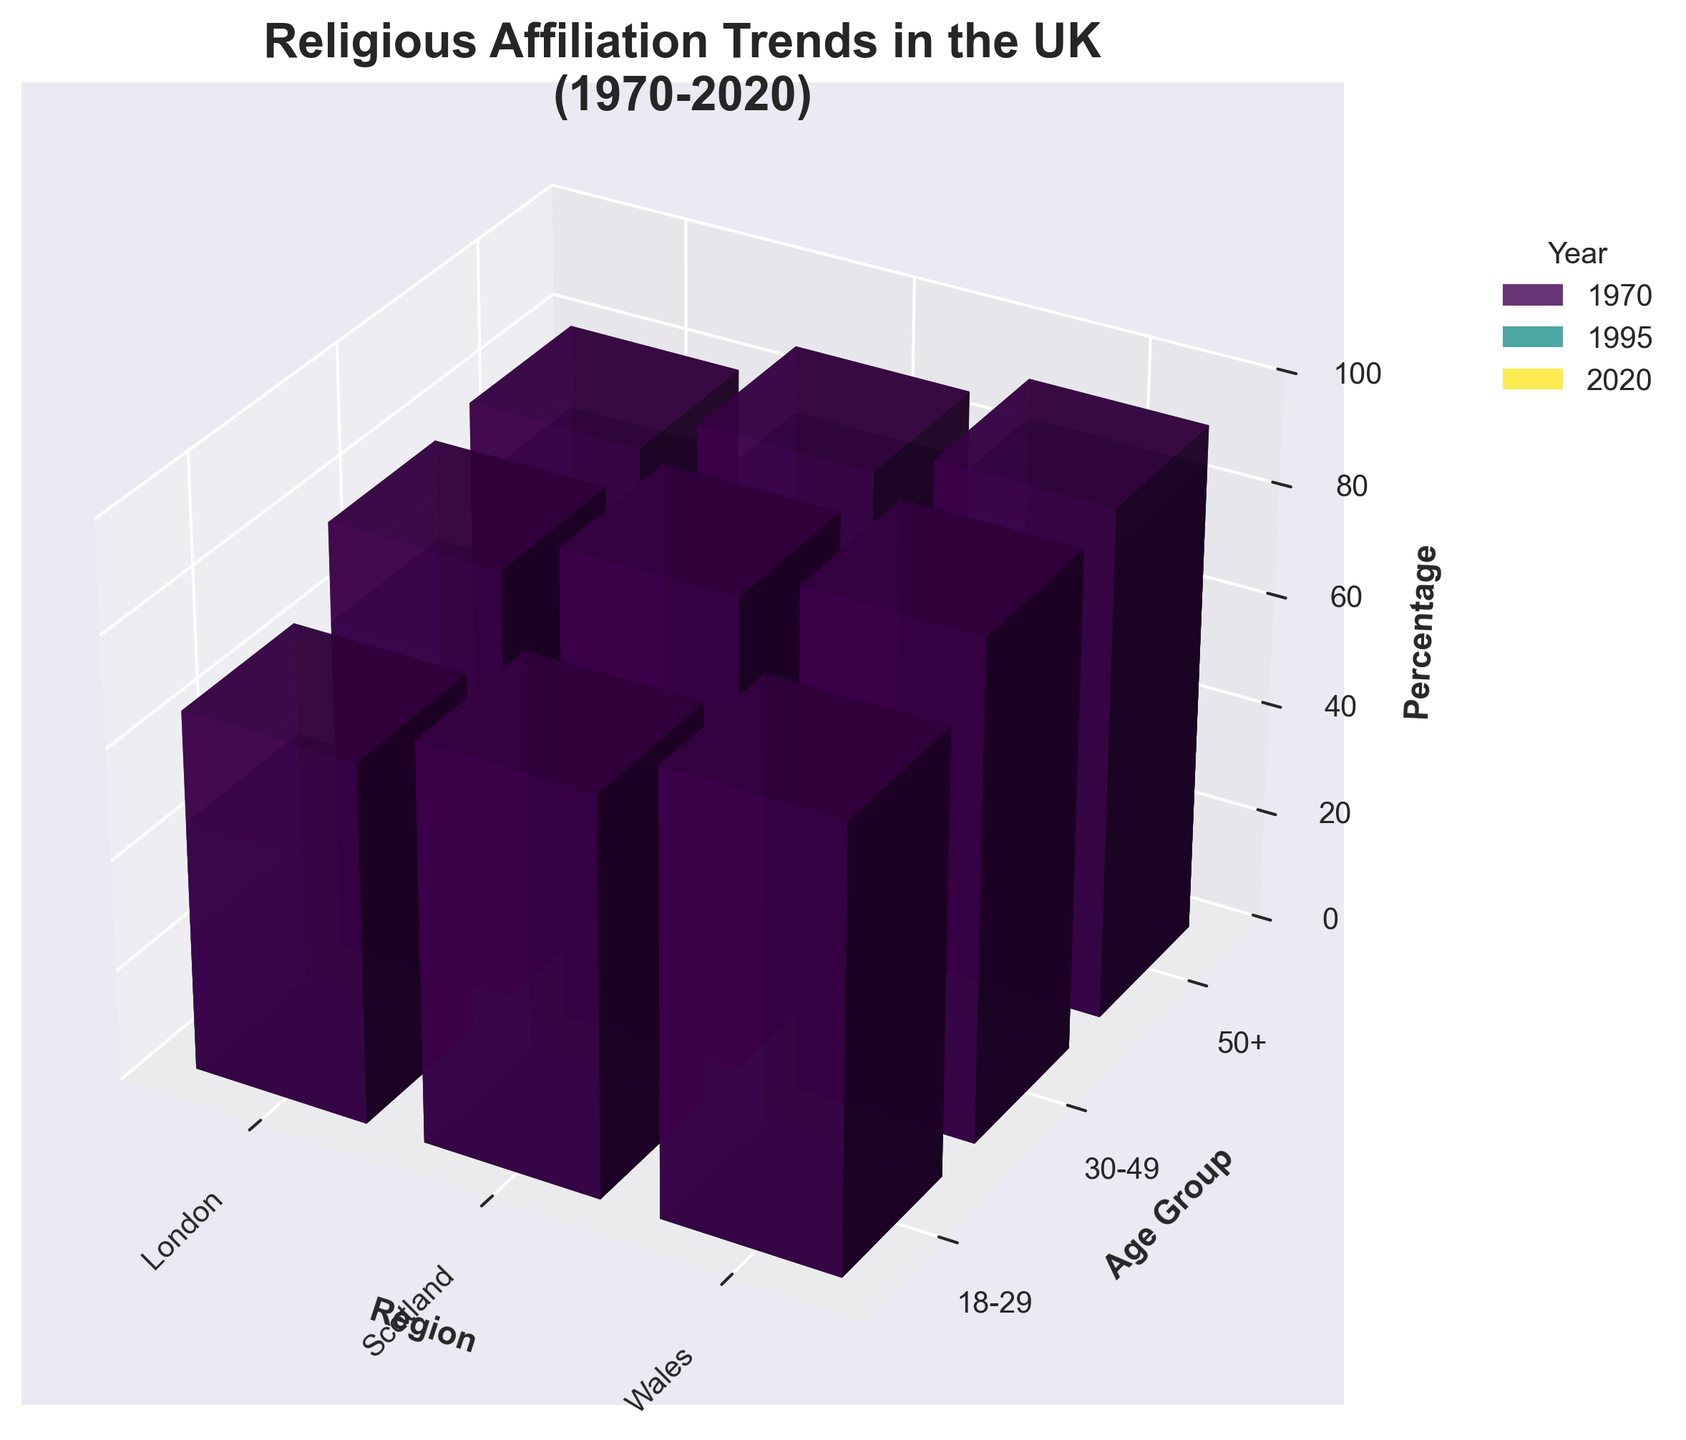What is the title of the plot? The title is prominently displayed at the top of the figure, indicating the general subject of the plot.
Answer: Religious Affiliation Trends in the UK (1970-2020) Which region showed the highest percentage of religious affiliation in 1970 for the age group 18-29? By examining the percentage bars for the year 1970, age group 18-29 across different regions, the bar for Wales is the highest.
Answer: Wales In the year 2020, which age group in London has the lowest percentage of religious affiliation? By looking at the heights of the 2020 bars for different age groups in London, the age group 18-29 has the shortest bar.
Answer: 18-29 How does the percentage of religious affiliation for the age group 50+ in Scotland change from 1970 to 2020? Compare the height of the bars corresponding to the age group 50+ in Scotland for the years 1970 and 2020. The height decreases from 90% to 60%.
Answer: Decreases Which year shows the greatest decline in the percentage points for the age group 18-29 in London compared to 1970? To find the greatest decline, compare the heights of bars for the age group 18-29 in London across 1970, 1995, and 2020. Calculate the differences: 1970-1995 and 1970-2020. The highest difference is between 1970 and 2020, which is 65% - 25% = 40 percentage points.
Answer: 2020 Which age group and region have the highest overall percentage of religious affiliation across all years? By examining the overall tallest bar across all age groups and regions for all years, it belongs to the 50+ age group in Wales for the year 1970, at 92%.
Answer: 50+ in Wales What is the average percentage of religious affiliation in Wales for the age group 30-49 across all years? Add the percentages for the age group 30-49 in Wales across 1970, 1995, and 2020, then divide by 3: (87 + 75 + 50) / 3 = 70.67.
Answer: 70.67 Which region shows the smallest decrease in religious affiliation from 1995 to 2020 for the age group 18-29? Compare the differences between the bar heights for the age group 18-29 from 1995 to 2020 across all regions. Wales decreases from 65% to 40%, Scotland from 60% to 35%, and London from 45% to 25%. Scotland shows the smallest decrease of 25 percentage points.
Answer: Scotland Is there any age group in London that had an increase in the percentage of religious affiliation from 1995 to 2020? By examining the bars for London from 1995 to 2020 for all age groups, none show an increase; all percentages decrease.
Answer: No How many data points (bars) are displayed in the figure? By counting the number of bars which correspond to the combinations of three years, three regions, and three age groups: 3 (years) * 3 (regions) * 3 (age groups) = 27 bars.
Answer: 27 